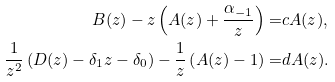<formula> <loc_0><loc_0><loc_500><loc_500>B ( z ) - z \left ( A ( z ) + \frac { \alpha _ { - 1 } } { z } \right ) = & c A ( z ) , \\ \frac { 1 } { z ^ { 2 } } \left ( D ( z ) - \delta _ { 1 } z - \delta _ { 0 } \right ) - \frac { 1 } { z } \left ( A ( z ) - 1 \right ) = & d A ( z ) .</formula> 